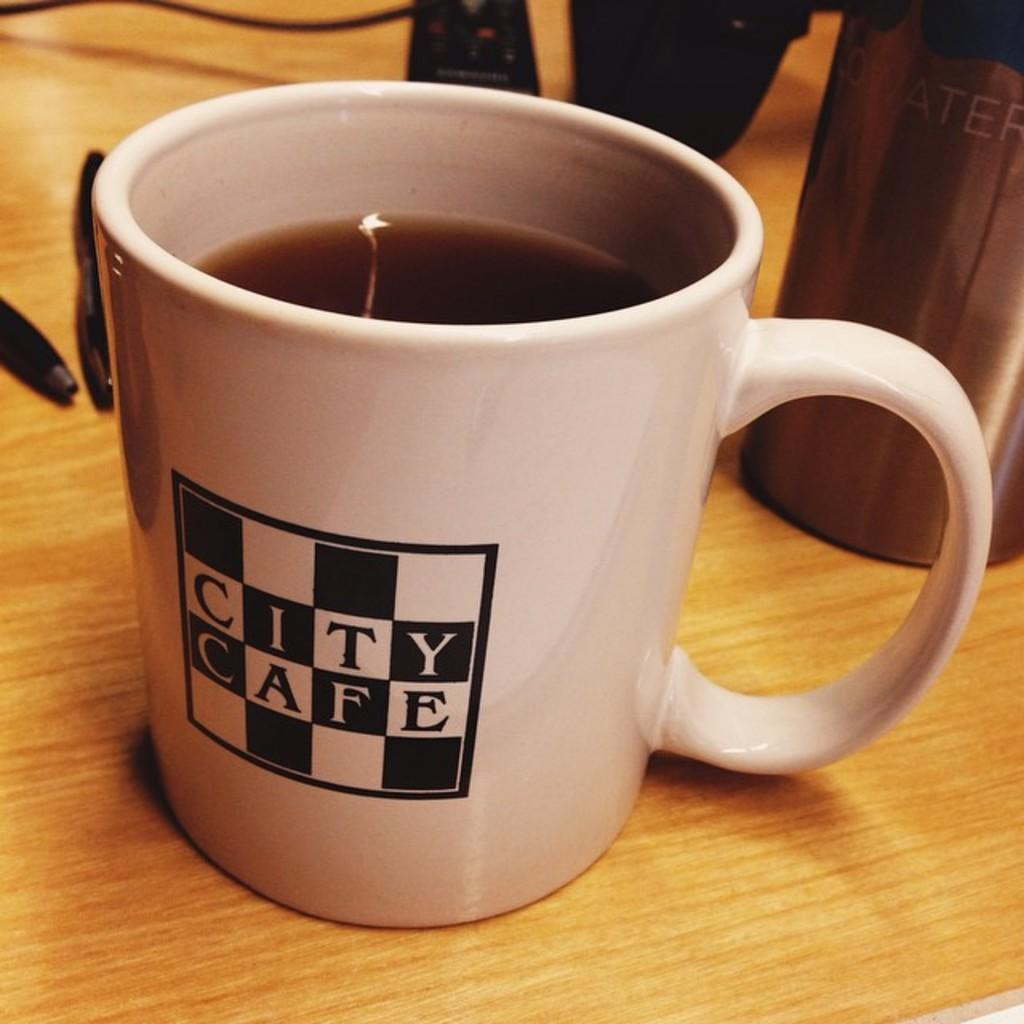What is in the cup that is visible in the image? There is a cup with coffee in the image. What can be seen on the table in the image besides the cup? There are pens on the table in the image. What other objects are present on the table in the image? There are other objects on the table in the image, but their specific details are not mentioned in the provided facts. What type of prose can be seen on the table in the image? There is no prose present on the table in the image. Is there any snow visible in the image? There is no snow present in the image. 